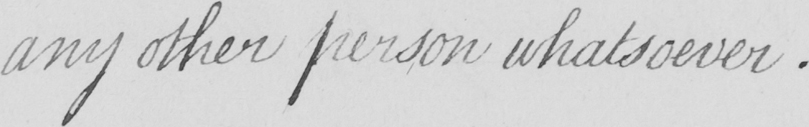Can you read and transcribe this handwriting? any other person whatsoever . 